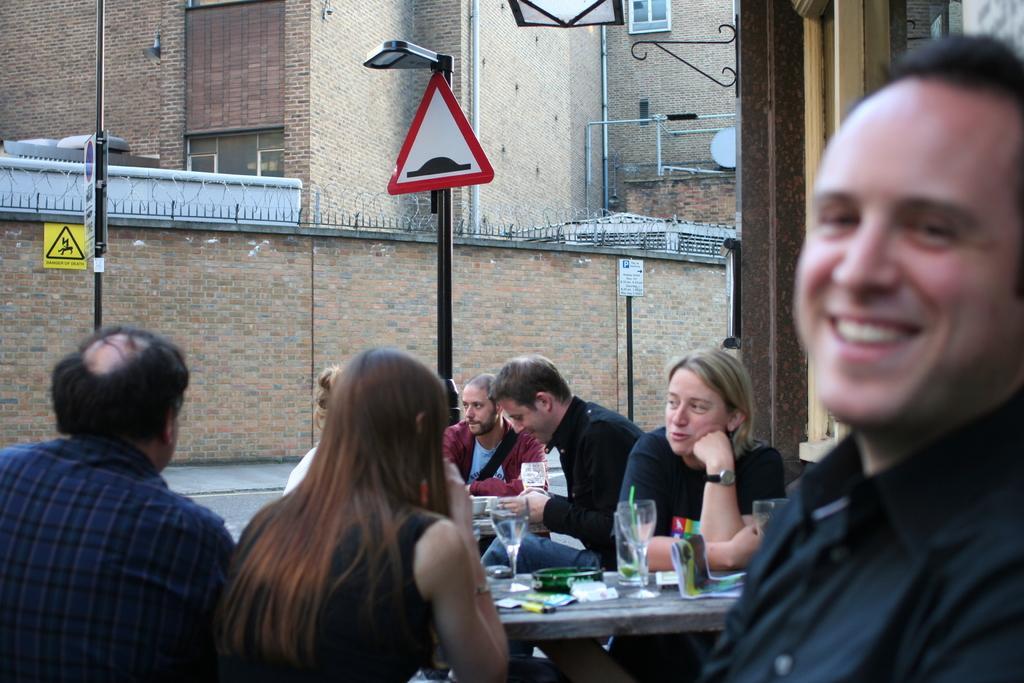Describe this image in one or two sentences. In this picture there are few persons sitting and there is a table in front of them which has few glasses and some other objects on it and there is a building in the background. 